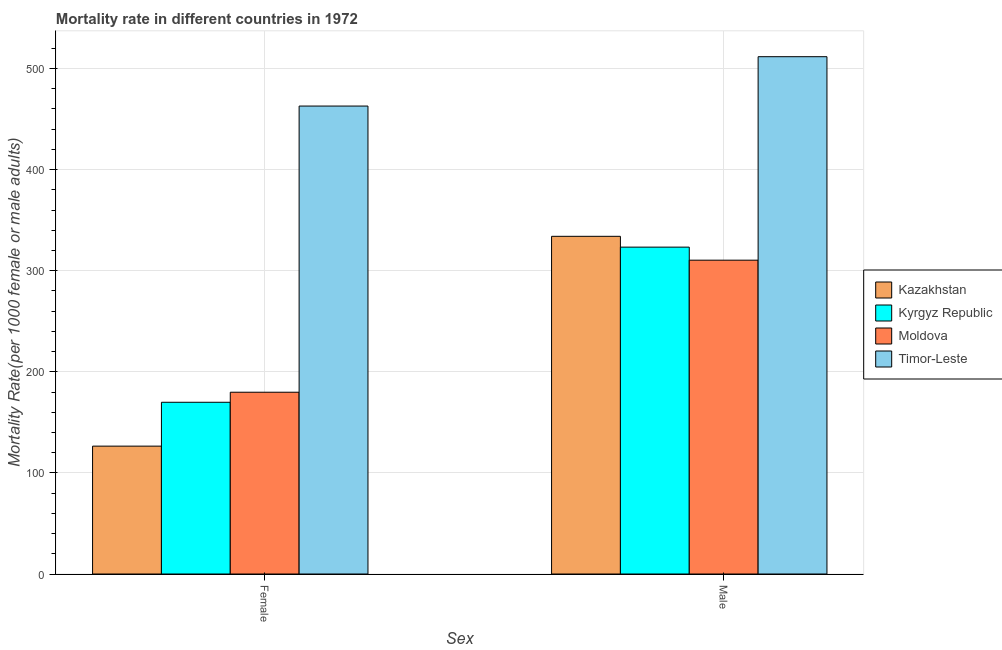How many different coloured bars are there?
Your answer should be very brief. 4. How many groups of bars are there?
Offer a terse response. 2. How many bars are there on the 1st tick from the right?
Your response must be concise. 4. What is the label of the 1st group of bars from the left?
Your answer should be very brief. Female. What is the female mortality rate in Timor-Leste?
Keep it short and to the point. 462.89. Across all countries, what is the maximum male mortality rate?
Give a very brief answer. 511.73. Across all countries, what is the minimum male mortality rate?
Give a very brief answer. 310.44. In which country was the male mortality rate maximum?
Provide a succinct answer. Timor-Leste. In which country was the female mortality rate minimum?
Offer a terse response. Kazakhstan. What is the total female mortality rate in the graph?
Your answer should be compact. 939.09. What is the difference between the male mortality rate in Timor-Leste and that in Kyrgyz Republic?
Provide a short and direct response. 188.39. What is the difference between the male mortality rate in Kyrgyz Republic and the female mortality rate in Kazakhstan?
Offer a terse response. 196.84. What is the average female mortality rate per country?
Offer a very short reply. 234.77. What is the difference between the female mortality rate and male mortality rate in Kazakhstan?
Your answer should be very brief. -207.53. What is the ratio of the female mortality rate in Kyrgyz Republic to that in Kazakhstan?
Give a very brief answer. 1.34. Is the male mortality rate in Timor-Leste less than that in Kazakhstan?
Ensure brevity in your answer.  No. What does the 2nd bar from the left in Female represents?
Your answer should be compact. Kyrgyz Republic. What does the 2nd bar from the right in Male represents?
Your answer should be very brief. Moldova. How many bars are there?
Make the answer very short. 8. What is the difference between two consecutive major ticks on the Y-axis?
Your answer should be compact. 100. Are the values on the major ticks of Y-axis written in scientific E-notation?
Your answer should be very brief. No. Does the graph contain any zero values?
Ensure brevity in your answer.  No. How many legend labels are there?
Offer a very short reply. 4. What is the title of the graph?
Give a very brief answer. Mortality rate in different countries in 1972. What is the label or title of the X-axis?
Offer a very short reply. Sex. What is the label or title of the Y-axis?
Your response must be concise. Mortality Rate(per 1000 female or male adults). What is the Mortality Rate(per 1000 female or male adults) in Kazakhstan in Female?
Your answer should be compact. 126.5. What is the Mortality Rate(per 1000 female or male adults) in Kyrgyz Republic in Female?
Keep it short and to the point. 169.88. What is the Mortality Rate(per 1000 female or male adults) in Moldova in Female?
Offer a terse response. 179.82. What is the Mortality Rate(per 1000 female or male adults) of Timor-Leste in Female?
Your answer should be compact. 462.89. What is the Mortality Rate(per 1000 female or male adults) of Kazakhstan in Male?
Your answer should be compact. 334.03. What is the Mortality Rate(per 1000 female or male adults) in Kyrgyz Republic in Male?
Your response must be concise. 323.34. What is the Mortality Rate(per 1000 female or male adults) of Moldova in Male?
Ensure brevity in your answer.  310.44. What is the Mortality Rate(per 1000 female or male adults) in Timor-Leste in Male?
Provide a short and direct response. 511.73. Across all Sex, what is the maximum Mortality Rate(per 1000 female or male adults) in Kazakhstan?
Offer a very short reply. 334.03. Across all Sex, what is the maximum Mortality Rate(per 1000 female or male adults) in Kyrgyz Republic?
Keep it short and to the point. 323.34. Across all Sex, what is the maximum Mortality Rate(per 1000 female or male adults) of Moldova?
Your answer should be very brief. 310.44. Across all Sex, what is the maximum Mortality Rate(per 1000 female or male adults) of Timor-Leste?
Offer a very short reply. 511.73. Across all Sex, what is the minimum Mortality Rate(per 1000 female or male adults) in Kazakhstan?
Ensure brevity in your answer.  126.5. Across all Sex, what is the minimum Mortality Rate(per 1000 female or male adults) of Kyrgyz Republic?
Provide a succinct answer. 169.88. Across all Sex, what is the minimum Mortality Rate(per 1000 female or male adults) in Moldova?
Ensure brevity in your answer.  179.82. Across all Sex, what is the minimum Mortality Rate(per 1000 female or male adults) in Timor-Leste?
Your response must be concise. 462.89. What is the total Mortality Rate(per 1000 female or male adults) of Kazakhstan in the graph?
Ensure brevity in your answer.  460.53. What is the total Mortality Rate(per 1000 female or male adults) of Kyrgyz Republic in the graph?
Make the answer very short. 493.22. What is the total Mortality Rate(per 1000 female or male adults) of Moldova in the graph?
Offer a very short reply. 490.25. What is the total Mortality Rate(per 1000 female or male adults) of Timor-Leste in the graph?
Make the answer very short. 974.62. What is the difference between the Mortality Rate(per 1000 female or male adults) in Kazakhstan in Female and that in Male?
Keep it short and to the point. -207.53. What is the difference between the Mortality Rate(per 1000 female or male adults) in Kyrgyz Republic in Female and that in Male?
Make the answer very short. -153.46. What is the difference between the Mortality Rate(per 1000 female or male adults) of Moldova in Female and that in Male?
Ensure brevity in your answer.  -130.62. What is the difference between the Mortality Rate(per 1000 female or male adults) in Timor-Leste in Female and that in Male?
Your response must be concise. -48.83. What is the difference between the Mortality Rate(per 1000 female or male adults) in Kazakhstan in Female and the Mortality Rate(per 1000 female or male adults) in Kyrgyz Republic in Male?
Make the answer very short. -196.84. What is the difference between the Mortality Rate(per 1000 female or male adults) of Kazakhstan in Female and the Mortality Rate(per 1000 female or male adults) of Moldova in Male?
Ensure brevity in your answer.  -183.94. What is the difference between the Mortality Rate(per 1000 female or male adults) of Kazakhstan in Female and the Mortality Rate(per 1000 female or male adults) of Timor-Leste in Male?
Offer a terse response. -385.23. What is the difference between the Mortality Rate(per 1000 female or male adults) of Kyrgyz Republic in Female and the Mortality Rate(per 1000 female or male adults) of Moldova in Male?
Keep it short and to the point. -140.56. What is the difference between the Mortality Rate(per 1000 female or male adults) in Kyrgyz Republic in Female and the Mortality Rate(per 1000 female or male adults) in Timor-Leste in Male?
Your answer should be very brief. -341.85. What is the difference between the Mortality Rate(per 1000 female or male adults) in Moldova in Female and the Mortality Rate(per 1000 female or male adults) in Timor-Leste in Male?
Offer a very short reply. -331.91. What is the average Mortality Rate(per 1000 female or male adults) of Kazakhstan per Sex?
Your answer should be compact. 230.26. What is the average Mortality Rate(per 1000 female or male adults) of Kyrgyz Republic per Sex?
Your answer should be compact. 246.61. What is the average Mortality Rate(per 1000 female or male adults) in Moldova per Sex?
Provide a succinct answer. 245.13. What is the average Mortality Rate(per 1000 female or male adults) in Timor-Leste per Sex?
Ensure brevity in your answer.  487.31. What is the difference between the Mortality Rate(per 1000 female or male adults) of Kazakhstan and Mortality Rate(per 1000 female or male adults) of Kyrgyz Republic in Female?
Provide a succinct answer. -43.38. What is the difference between the Mortality Rate(per 1000 female or male adults) of Kazakhstan and Mortality Rate(per 1000 female or male adults) of Moldova in Female?
Make the answer very short. -53.32. What is the difference between the Mortality Rate(per 1000 female or male adults) of Kazakhstan and Mortality Rate(per 1000 female or male adults) of Timor-Leste in Female?
Provide a succinct answer. -336.4. What is the difference between the Mortality Rate(per 1000 female or male adults) of Kyrgyz Republic and Mortality Rate(per 1000 female or male adults) of Moldova in Female?
Give a very brief answer. -9.94. What is the difference between the Mortality Rate(per 1000 female or male adults) in Kyrgyz Republic and Mortality Rate(per 1000 female or male adults) in Timor-Leste in Female?
Provide a short and direct response. -293.01. What is the difference between the Mortality Rate(per 1000 female or male adults) of Moldova and Mortality Rate(per 1000 female or male adults) of Timor-Leste in Female?
Make the answer very short. -283.07. What is the difference between the Mortality Rate(per 1000 female or male adults) of Kazakhstan and Mortality Rate(per 1000 female or male adults) of Kyrgyz Republic in Male?
Provide a short and direct response. 10.69. What is the difference between the Mortality Rate(per 1000 female or male adults) in Kazakhstan and Mortality Rate(per 1000 female or male adults) in Moldova in Male?
Ensure brevity in your answer.  23.59. What is the difference between the Mortality Rate(per 1000 female or male adults) of Kazakhstan and Mortality Rate(per 1000 female or male adults) of Timor-Leste in Male?
Offer a terse response. -177.7. What is the difference between the Mortality Rate(per 1000 female or male adults) of Kyrgyz Republic and Mortality Rate(per 1000 female or male adults) of Moldova in Male?
Give a very brief answer. 12.9. What is the difference between the Mortality Rate(per 1000 female or male adults) of Kyrgyz Republic and Mortality Rate(per 1000 female or male adults) of Timor-Leste in Male?
Your response must be concise. -188.39. What is the difference between the Mortality Rate(per 1000 female or male adults) in Moldova and Mortality Rate(per 1000 female or male adults) in Timor-Leste in Male?
Ensure brevity in your answer.  -201.29. What is the ratio of the Mortality Rate(per 1000 female or male adults) of Kazakhstan in Female to that in Male?
Your answer should be compact. 0.38. What is the ratio of the Mortality Rate(per 1000 female or male adults) in Kyrgyz Republic in Female to that in Male?
Your answer should be very brief. 0.53. What is the ratio of the Mortality Rate(per 1000 female or male adults) in Moldova in Female to that in Male?
Your answer should be compact. 0.58. What is the ratio of the Mortality Rate(per 1000 female or male adults) of Timor-Leste in Female to that in Male?
Your answer should be very brief. 0.9. What is the difference between the highest and the second highest Mortality Rate(per 1000 female or male adults) of Kazakhstan?
Offer a very short reply. 207.53. What is the difference between the highest and the second highest Mortality Rate(per 1000 female or male adults) of Kyrgyz Republic?
Keep it short and to the point. 153.46. What is the difference between the highest and the second highest Mortality Rate(per 1000 female or male adults) of Moldova?
Keep it short and to the point. 130.62. What is the difference between the highest and the second highest Mortality Rate(per 1000 female or male adults) in Timor-Leste?
Provide a short and direct response. 48.83. What is the difference between the highest and the lowest Mortality Rate(per 1000 female or male adults) in Kazakhstan?
Your answer should be very brief. 207.53. What is the difference between the highest and the lowest Mortality Rate(per 1000 female or male adults) in Kyrgyz Republic?
Ensure brevity in your answer.  153.46. What is the difference between the highest and the lowest Mortality Rate(per 1000 female or male adults) in Moldova?
Offer a very short reply. 130.62. What is the difference between the highest and the lowest Mortality Rate(per 1000 female or male adults) in Timor-Leste?
Your answer should be very brief. 48.83. 